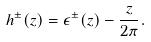<formula> <loc_0><loc_0><loc_500><loc_500>h ^ { \pm } ( z ) = \epsilon ^ { \pm } ( z ) - \frac { z } { 2 \pi } .</formula> 